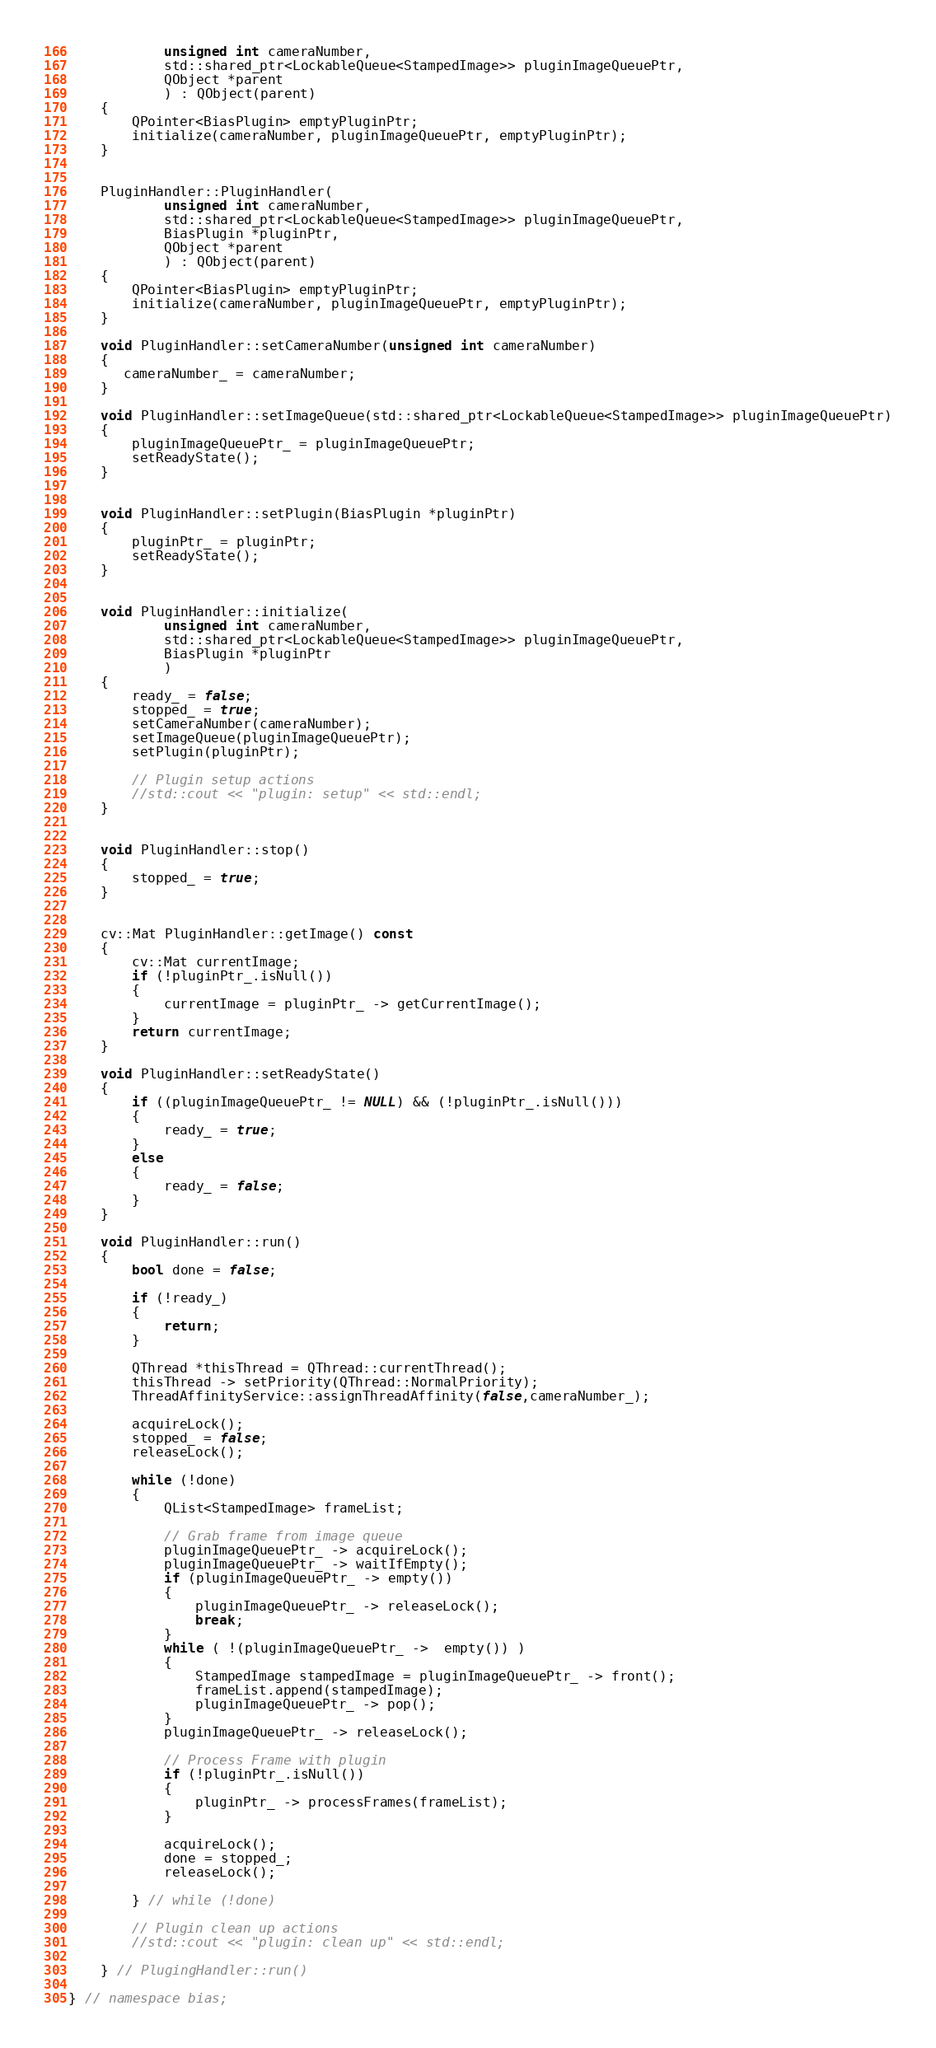<code> <loc_0><loc_0><loc_500><loc_500><_C++_>            unsigned int cameraNumber,
            std::shared_ptr<LockableQueue<StampedImage>> pluginImageQueuePtr,
            QObject *parent
            ) : QObject(parent)
    {
        QPointer<BiasPlugin> emptyPluginPtr;
        initialize(cameraNumber, pluginImageQueuePtr, emptyPluginPtr);
    }


    PluginHandler::PluginHandler(
            unsigned int cameraNumber,
            std::shared_ptr<LockableQueue<StampedImage>> pluginImageQueuePtr,
            BiasPlugin *pluginPtr,
            QObject *parent
            ) : QObject(parent)
    {
        QPointer<BiasPlugin> emptyPluginPtr;
        initialize(cameraNumber, pluginImageQueuePtr, emptyPluginPtr);
    }

    void PluginHandler::setCameraNumber(unsigned int cameraNumber)
    {
       cameraNumber_ = cameraNumber;
    } 

    void PluginHandler::setImageQueue(std::shared_ptr<LockableQueue<StampedImage>> pluginImageQueuePtr)
    {
        pluginImageQueuePtr_ = pluginImageQueuePtr;
        setReadyState();
    }


    void PluginHandler::setPlugin(BiasPlugin *pluginPtr)
    {
        pluginPtr_ = pluginPtr;
        setReadyState();
    }


    void PluginHandler::initialize(
            unsigned int cameraNumber,
            std::shared_ptr<LockableQueue<StampedImage>> pluginImageQueuePtr,
            BiasPlugin *pluginPtr
            )
    {
        ready_ = false;
        stopped_ = true;
        setCameraNumber(cameraNumber);
        setImageQueue(pluginImageQueuePtr);
        setPlugin(pluginPtr);

        // Plugin setup actions
        //std::cout << "plugin: setup" << std::endl;
    }


    void PluginHandler::stop()
    {
        stopped_ = true;
    }


    cv::Mat PluginHandler::getImage() const
    {
        cv::Mat currentImage;
        if (!pluginPtr_.isNull())
        {
            currentImage = pluginPtr_ -> getCurrentImage();
        }
        return currentImage;
    }

    void PluginHandler::setReadyState()
    {
        if ((pluginImageQueuePtr_ != NULL) && (!pluginPtr_.isNull()))
        {
            ready_ = true;
        }
        else
        {
            ready_ = false;
        }
    }

    void PluginHandler::run()
    {
        bool done = false;

        if (!ready_) 
        { 
            return; 
        }

        QThread *thisThread = QThread::currentThread();
        thisThread -> setPriority(QThread::NormalPriority);
        ThreadAffinityService::assignThreadAffinity(false,cameraNumber_);

        acquireLock();
        stopped_ = false;
        releaseLock();

        while (!done)
        {
            QList<StampedImage> frameList;

            // Grab frame from image queue
            pluginImageQueuePtr_ -> acquireLock();
            pluginImageQueuePtr_ -> waitIfEmpty();
            if (pluginImageQueuePtr_ -> empty())
            {
                pluginImageQueuePtr_ -> releaseLock();
                break;
            }
            while ( !(pluginImageQueuePtr_ ->  empty()) )
            {
                StampedImage stampedImage = pluginImageQueuePtr_ -> front();
                frameList.append(stampedImage);
                pluginImageQueuePtr_ -> pop();
            }
            pluginImageQueuePtr_ -> releaseLock();

            // Process Frame with plugin
            if (!pluginPtr_.isNull())
            {
                pluginPtr_ -> processFrames(frameList);
            }
            
            acquireLock();
            done = stopped_;
            releaseLock();

        } // while (!done)

        // Plugin clean up actions
        //std::cout << "plugin: clean up" << std::endl;

    } // PlugingHandler::run()

} // namespace bias;
</code> 